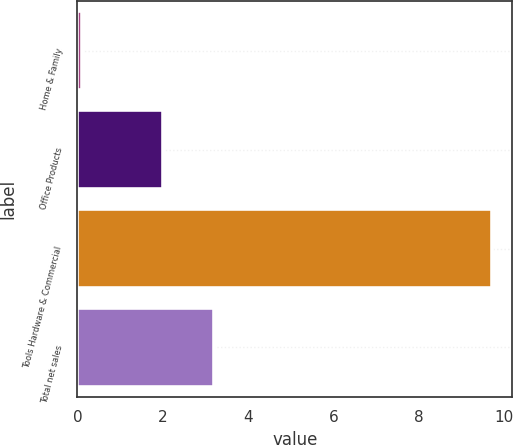<chart> <loc_0><loc_0><loc_500><loc_500><bar_chart><fcel>Home & Family<fcel>Office Products<fcel>Tools Hardware & Commercial<fcel>Total net sales<nl><fcel>0.1<fcel>2<fcel>9.7<fcel>3.2<nl></chart> 